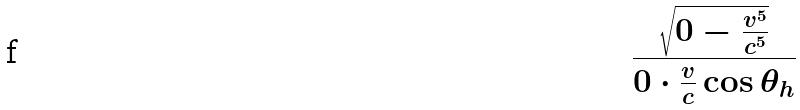Convert formula to latex. <formula><loc_0><loc_0><loc_500><loc_500>\frac { \sqrt { 0 - \frac { v ^ { 5 } } { c ^ { 5 } } } } { 0 \cdot \frac { v } { c } \cos \theta _ { h } }</formula> 